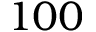<formula> <loc_0><loc_0><loc_500><loc_500>1 0 0</formula> 